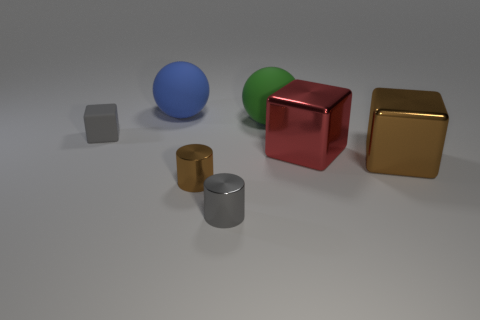Add 1 tiny purple cylinders. How many objects exist? 8 Subtract all spheres. How many objects are left? 5 Subtract all cyan matte things. Subtract all big brown blocks. How many objects are left? 6 Add 4 metallic cylinders. How many metallic cylinders are left? 6 Add 2 cylinders. How many cylinders exist? 4 Subtract 0 yellow cubes. How many objects are left? 7 